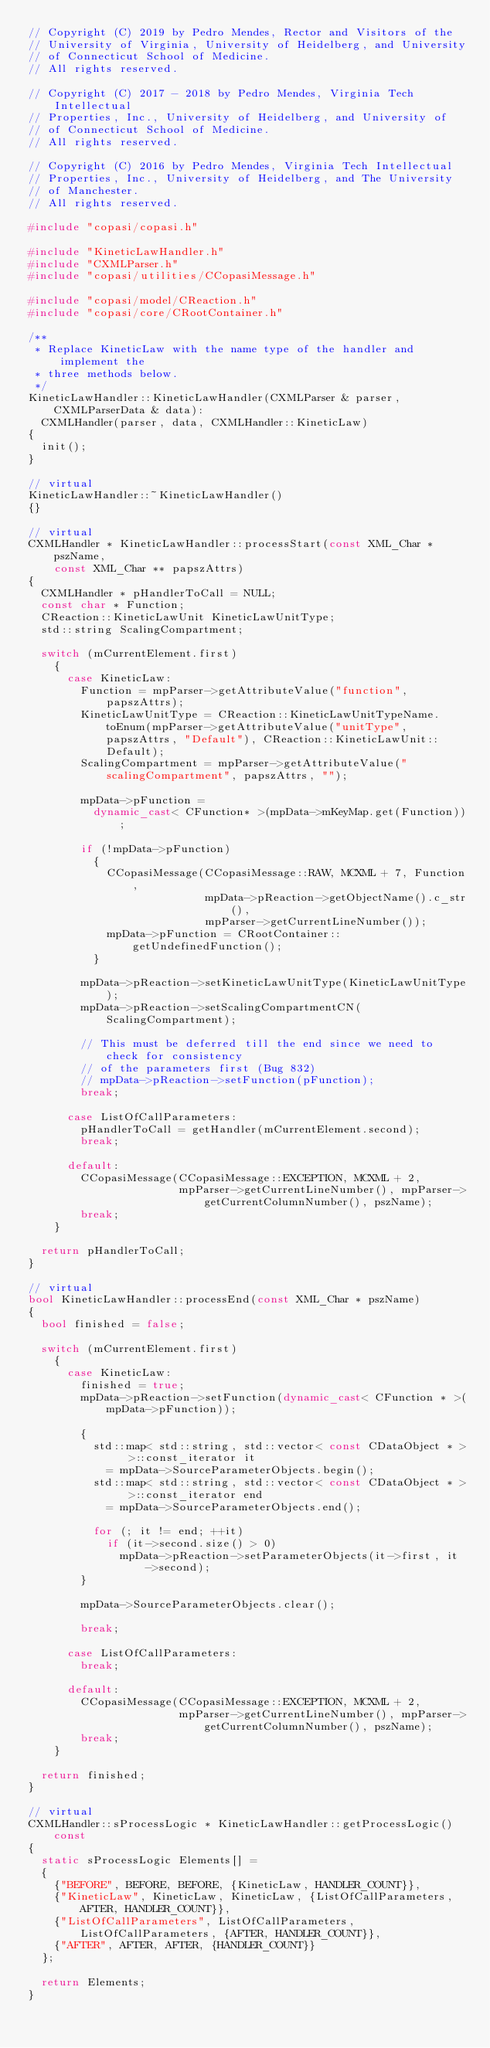<code> <loc_0><loc_0><loc_500><loc_500><_C++_>// Copyright (C) 2019 by Pedro Mendes, Rector and Visitors of the
// University of Virginia, University of Heidelberg, and University
// of Connecticut School of Medicine.
// All rights reserved.

// Copyright (C) 2017 - 2018 by Pedro Mendes, Virginia Tech Intellectual
// Properties, Inc., University of Heidelberg, and University of
// of Connecticut School of Medicine.
// All rights reserved.

// Copyright (C) 2016 by Pedro Mendes, Virginia Tech Intellectual
// Properties, Inc., University of Heidelberg, and The University
// of Manchester.
// All rights reserved.

#include "copasi/copasi.h"

#include "KineticLawHandler.h"
#include "CXMLParser.h"
#include "copasi/utilities/CCopasiMessage.h"

#include "copasi/model/CReaction.h"
#include "copasi/core/CRootContainer.h"

/**
 * Replace KineticLaw with the name type of the handler and implement the
 * three methods below.
 */
KineticLawHandler::KineticLawHandler(CXMLParser & parser, CXMLParserData & data):
  CXMLHandler(parser, data, CXMLHandler::KineticLaw)
{
  init();
}

// virtual
KineticLawHandler::~KineticLawHandler()
{}

// virtual
CXMLHandler * KineticLawHandler::processStart(const XML_Char * pszName,
    const XML_Char ** papszAttrs)
{
  CXMLHandler * pHandlerToCall = NULL;
  const char * Function;
  CReaction::KineticLawUnit KineticLawUnitType;
  std::string ScalingCompartment;

  switch (mCurrentElement.first)
    {
      case KineticLaw:
        Function = mpParser->getAttributeValue("function", papszAttrs);
        KineticLawUnitType = CReaction::KineticLawUnitTypeName.toEnum(mpParser->getAttributeValue("unitType", papszAttrs, "Default"), CReaction::KineticLawUnit::Default);
        ScalingCompartment = mpParser->getAttributeValue("scalingCompartment", papszAttrs, "");

        mpData->pFunction =
          dynamic_cast< CFunction* >(mpData->mKeyMap.get(Function));

        if (!mpData->pFunction)
          {
            CCopasiMessage(CCopasiMessage::RAW, MCXML + 7, Function,
                           mpData->pReaction->getObjectName().c_str(),
                           mpParser->getCurrentLineNumber());
            mpData->pFunction = CRootContainer::getUndefinedFunction();
          }

        mpData->pReaction->setKineticLawUnitType(KineticLawUnitType);
        mpData->pReaction->setScalingCompartmentCN(ScalingCompartment);

        // This must be deferred till the end since we need to check for consistency
        // of the parameters first (Bug 832)
        // mpData->pReaction->setFunction(pFunction);
        break;

      case ListOfCallParameters:
        pHandlerToCall = getHandler(mCurrentElement.second);
        break;

      default:
        CCopasiMessage(CCopasiMessage::EXCEPTION, MCXML + 2,
                       mpParser->getCurrentLineNumber(), mpParser->getCurrentColumnNumber(), pszName);
        break;
    }

  return pHandlerToCall;
}

// virtual
bool KineticLawHandler::processEnd(const XML_Char * pszName)
{
  bool finished = false;

  switch (mCurrentElement.first)
    {
      case KineticLaw:
        finished = true;
        mpData->pReaction->setFunction(dynamic_cast< CFunction * >(mpData->pFunction));

        {
          std::map< std::string, std::vector< const CDataObject * > >::const_iterator it
            = mpData->SourceParameterObjects.begin();
          std::map< std::string, std::vector< const CDataObject * > >::const_iterator end
            = mpData->SourceParameterObjects.end();

          for (; it != end; ++it)
            if (it->second.size() > 0)
              mpData->pReaction->setParameterObjects(it->first, it->second);
        }

        mpData->SourceParameterObjects.clear();

        break;

      case ListOfCallParameters:
        break;

      default:
        CCopasiMessage(CCopasiMessage::EXCEPTION, MCXML + 2,
                       mpParser->getCurrentLineNumber(), mpParser->getCurrentColumnNumber(), pszName);
        break;
    }

  return finished;
}

// virtual
CXMLHandler::sProcessLogic * KineticLawHandler::getProcessLogic() const
{
  static sProcessLogic Elements[] =
  {
    {"BEFORE", BEFORE, BEFORE, {KineticLaw, HANDLER_COUNT}},
    {"KineticLaw", KineticLaw, KineticLaw, {ListOfCallParameters, AFTER, HANDLER_COUNT}},
    {"ListOfCallParameters", ListOfCallParameters, ListOfCallParameters, {AFTER, HANDLER_COUNT}},
    {"AFTER", AFTER, AFTER, {HANDLER_COUNT}}
  };

  return Elements;
}
</code> 